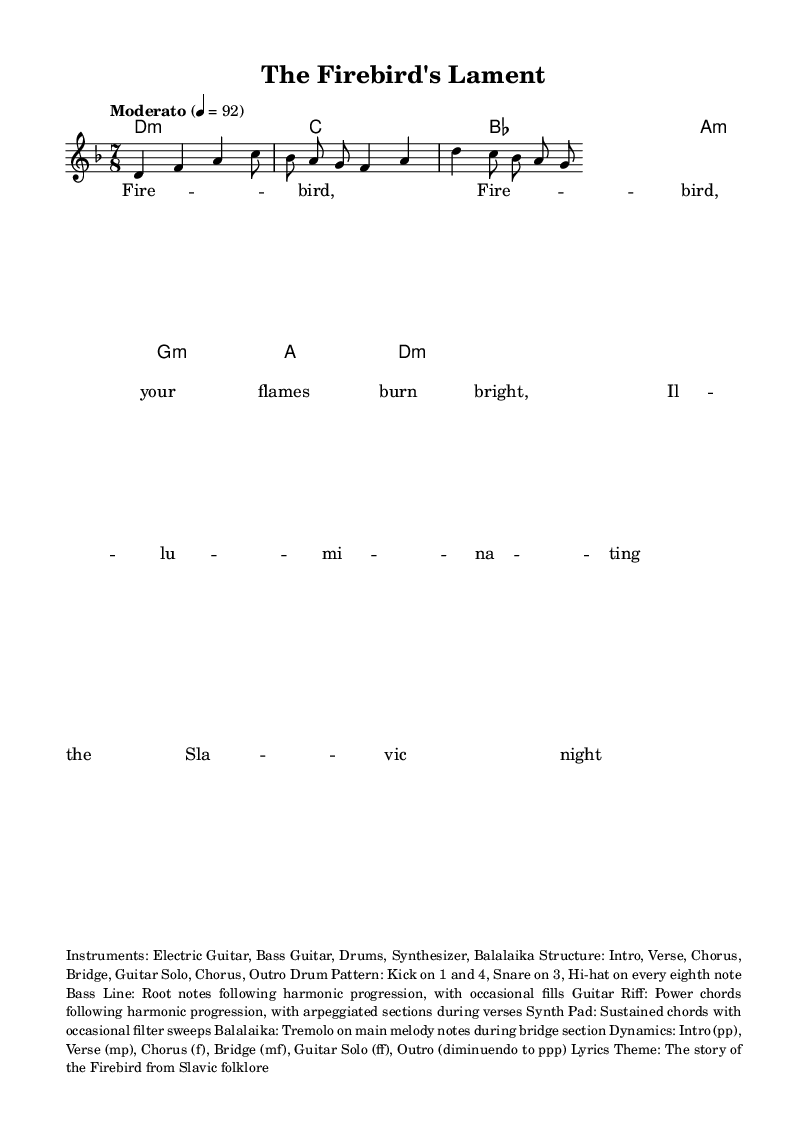What is the key signature of this music? The key signature indicates D minor, which includes one flat (B flat) to create the minor sound.
Answer: D minor What is the time signature? The time signature is displayed at the beginning of the staff as 7/8, indicating seven eighth-note beats per measure.
Answer: 7/8 What is the tempo marking? The tempo marking is "Moderato," which is often interpreted as a moderate speed, and is set to a tempo of 92 beats per minute.
Answer: Moderato What instruments are indicated in the piece? The instruments are listed in the markup section; they include Electric Guitar, Bass Guitar, Drums, Synthesizer, and Balalaika.
Answer: Electric Guitar, Bass Guitar, Drums, Synthesizer, Balalaika What is the dynamic marking for the Chorus section? The dynamic marking for the Chorus section is marked as "f," which stands for "forte," indicating a loud volume.
Answer: f How is the guitar riff structured? The guitar riff follows the harmonic progression with power chords and features arpeggiated sections during the verses, according to the structure mentioned in the markup.
Answer: Power chords with arpeggiated sections What story do the lyrics convey? The lyrics tell the story of the Firebird from Slavic folklore, conveying themes of illumination and magic through the repeated refrain.
Answer: The story of the Firebird 